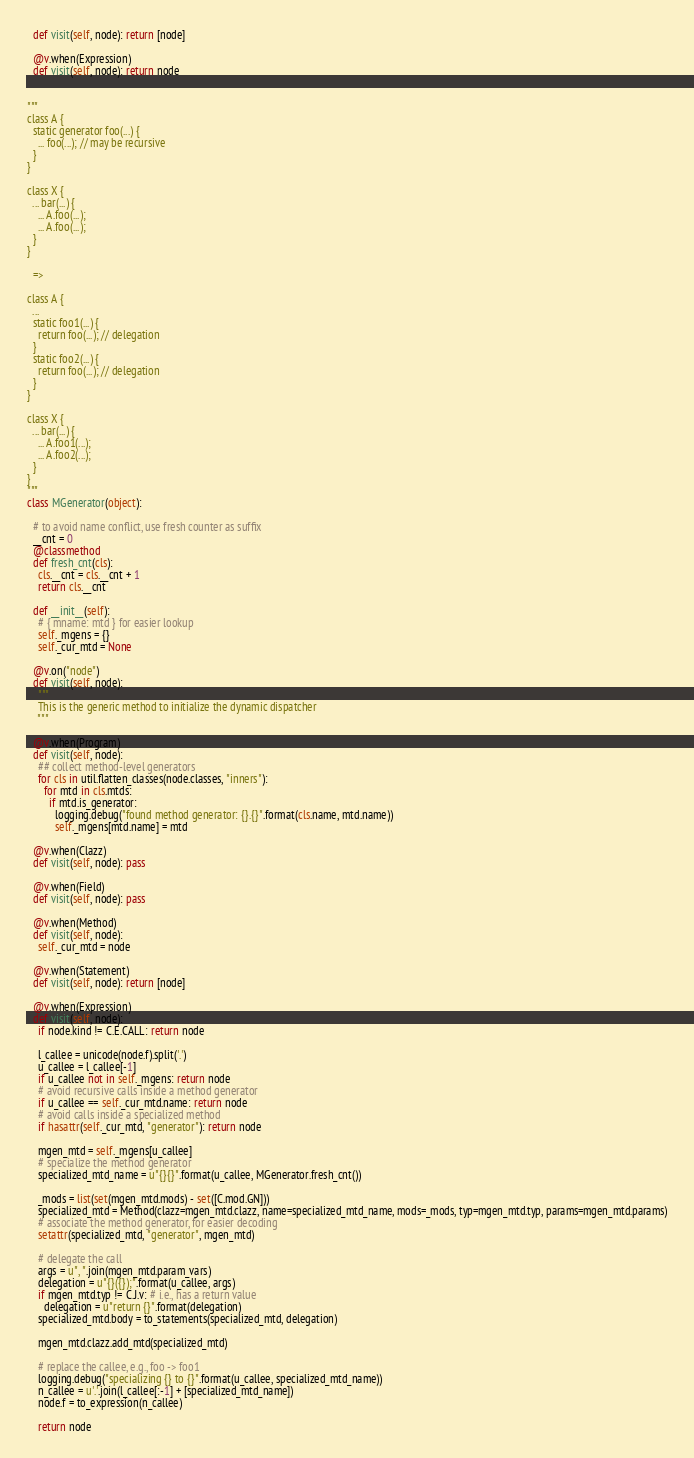Convert code to text. <code><loc_0><loc_0><loc_500><loc_500><_Python_>  def visit(self, node): return [node]

  @v.when(Expression)
  def visit(self, node): return node


"""
class A {
  static generator foo(...) {
    ... foo(...); // may be recursive
  }
}

class X {
  ... bar(...) {
    ... A.foo(...);
    ... A.foo(...);
  }
}

  =>

class A {
  ...
  static foo1(...) {
    return foo(...); // delegation
  }
  static foo2(...) {
    return foo(...); // delegation
  }
}

class X {
  ... bar(...) {
    ... A.foo1(...);
    ... A.foo2(...);
  }
}
"""
class MGenerator(object):

  # to avoid name conflict, use fresh counter as suffix
  __cnt = 0
  @classmethod
  def fresh_cnt(cls):
    cls.__cnt = cls.__cnt + 1
    return cls.__cnt

  def __init__(self):
    # { mname: mtd } for easier lookup
    self._mgens = {}
    self._cur_mtd = None

  @v.on("node")
  def visit(self, node):
    """
    This is the generic method to initialize the dynamic dispatcher
    """

  @v.when(Program)
  def visit(self, node):
    ## collect method-level generators
    for cls in util.flatten_classes(node.classes, "inners"):
      for mtd in cls.mtds:
        if mtd.is_generator:
          logging.debug("found method generator: {}.{}".format(cls.name, mtd.name))
          self._mgens[mtd.name] = mtd

  @v.when(Clazz)
  def visit(self, node): pass

  @v.when(Field)
  def visit(self, node): pass

  @v.when(Method)
  def visit(self, node):
    self._cur_mtd = node

  @v.when(Statement)
  def visit(self, node): return [node]

  @v.when(Expression)
  def visit(self, node):
    if node.kind != C.E.CALL: return node

    l_callee = unicode(node.f).split('.')
    u_callee = l_callee[-1]
    if u_callee not in self._mgens: return node
    # avoid recursive calls inside a method generator
    if u_callee == self._cur_mtd.name: return node
    # avoid calls inside a specialized method
    if hasattr(self._cur_mtd, "generator"): return node

    mgen_mtd = self._mgens[u_callee]
    # specialize the method generator
    specialized_mtd_name = u"{}{}".format(u_callee, MGenerator.fresh_cnt())

    _mods = list(set(mgen_mtd.mods) - set([C.mod.GN]))
    specialized_mtd = Method(clazz=mgen_mtd.clazz, name=specialized_mtd_name, mods=_mods, typ=mgen_mtd.typ, params=mgen_mtd.params)
    # associate the method generator, for easier decoding
    setattr(specialized_mtd, "generator", mgen_mtd)

    # delegate the call
    args = u", ".join(mgen_mtd.param_vars)
    delegation = u"{}({});".format(u_callee, args)
    if mgen_mtd.typ != C.J.v: # i.e., has a return value
      delegation = u"return {}".format(delegation)
    specialized_mtd.body = to_statements(specialized_mtd, delegation)

    mgen_mtd.clazz.add_mtd(specialized_mtd)

    # replace the callee, e.g., foo -> foo1
    logging.debug("specializing {} to {}".format(u_callee, specialized_mtd_name))
    n_callee = u'.'.join(l_callee[:-1] + [specialized_mtd_name])
    node.f = to_expression(n_callee)

    return node

</code> 